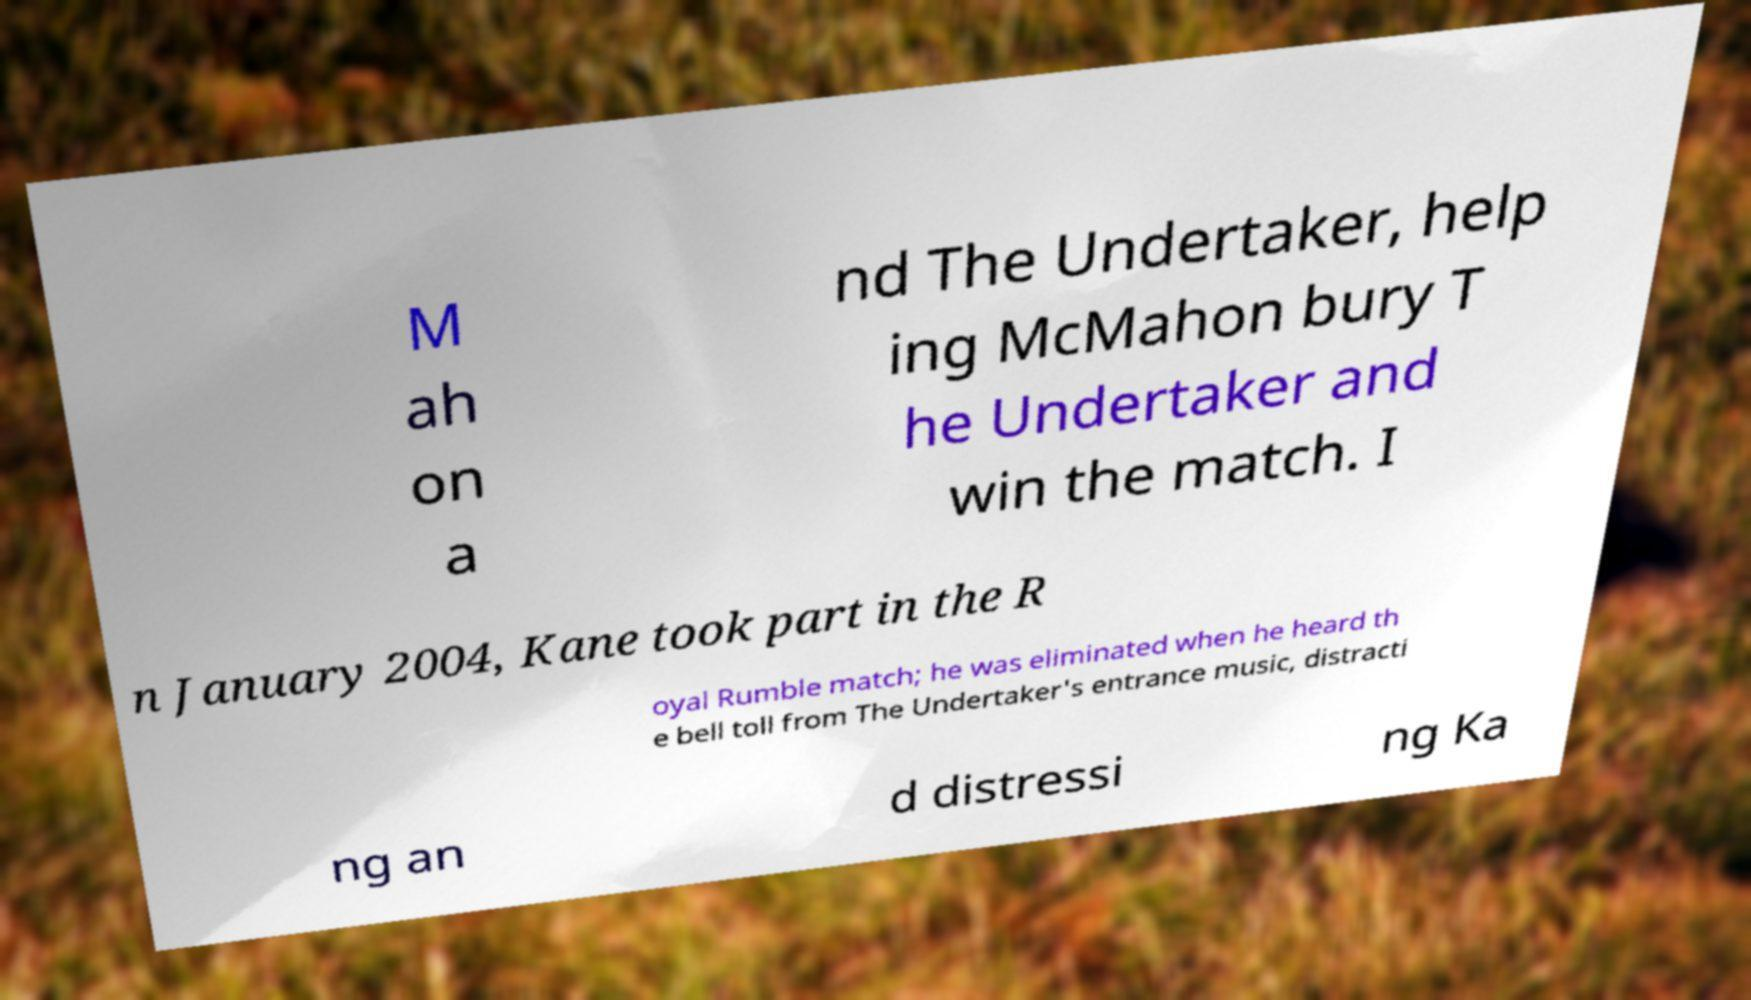Please read and relay the text visible in this image. What does it say? M ah on a nd The Undertaker, help ing McMahon bury T he Undertaker and win the match. I n January 2004, Kane took part in the R oyal Rumble match; he was eliminated when he heard th e bell toll from The Undertaker's entrance music, distracti ng an d distressi ng Ka 